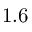<formula> <loc_0><loc_0><loc_500><loc_500>1 . 6</formula> 